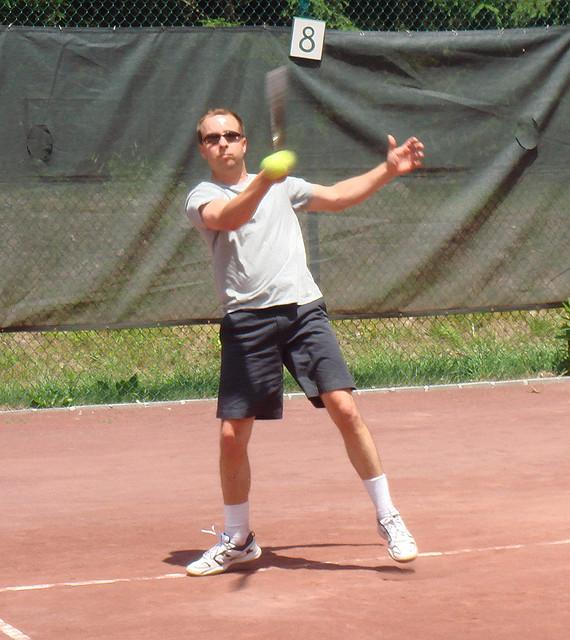Why is the man wearing glasses? Please explain your reasoning. block sunlight. The man is blocking sunlight. 